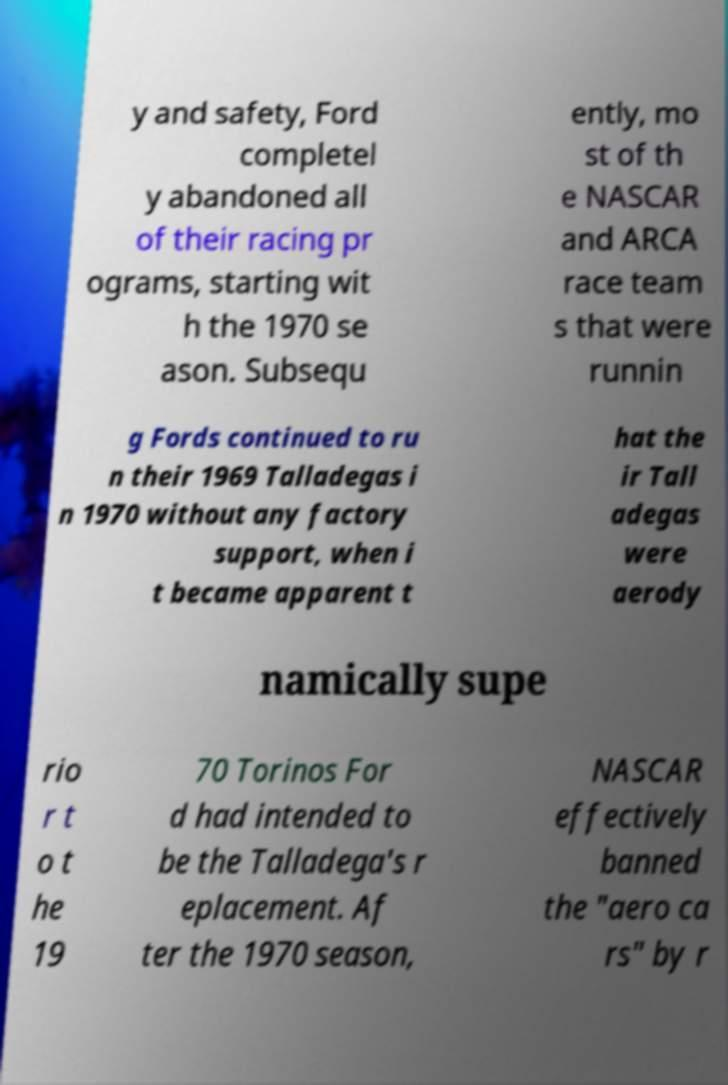Please read and relay the text visible in this image. What does it say? y and safety, Ford completel y abandoned all of their racing pr ograms, starting wit h the 1970 se ason. Subsequ ently, mo st of th e NASCAR and ARCA race team s that were runnin g Fords continued to ru n their 1969 Talladegas i n 1970 without any factory support, when i t became apparent t hat the ir Tall adegas were aerody namically supe rio r t o t he 19 70 Torinos For d had intended to be the Talladega's r eplacement. Af ter the 1970 season, NASCAR effectively banned the "aero ca rs" by r 